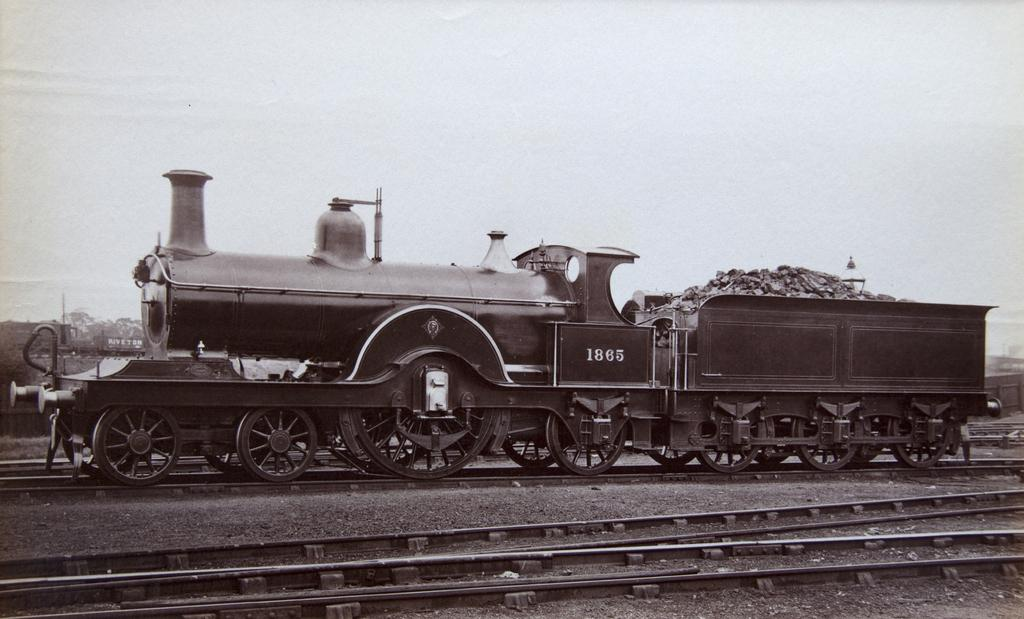What is the color scheme of the image? The image is black and white. What can be seen on the ground in the image? There are tracks in the image. What is located on the tracks in the image? There is a train on the tracks. How does the train show respect to the foot in the image? There is no foot present in the image, and the train does not show respect to any object or person. 